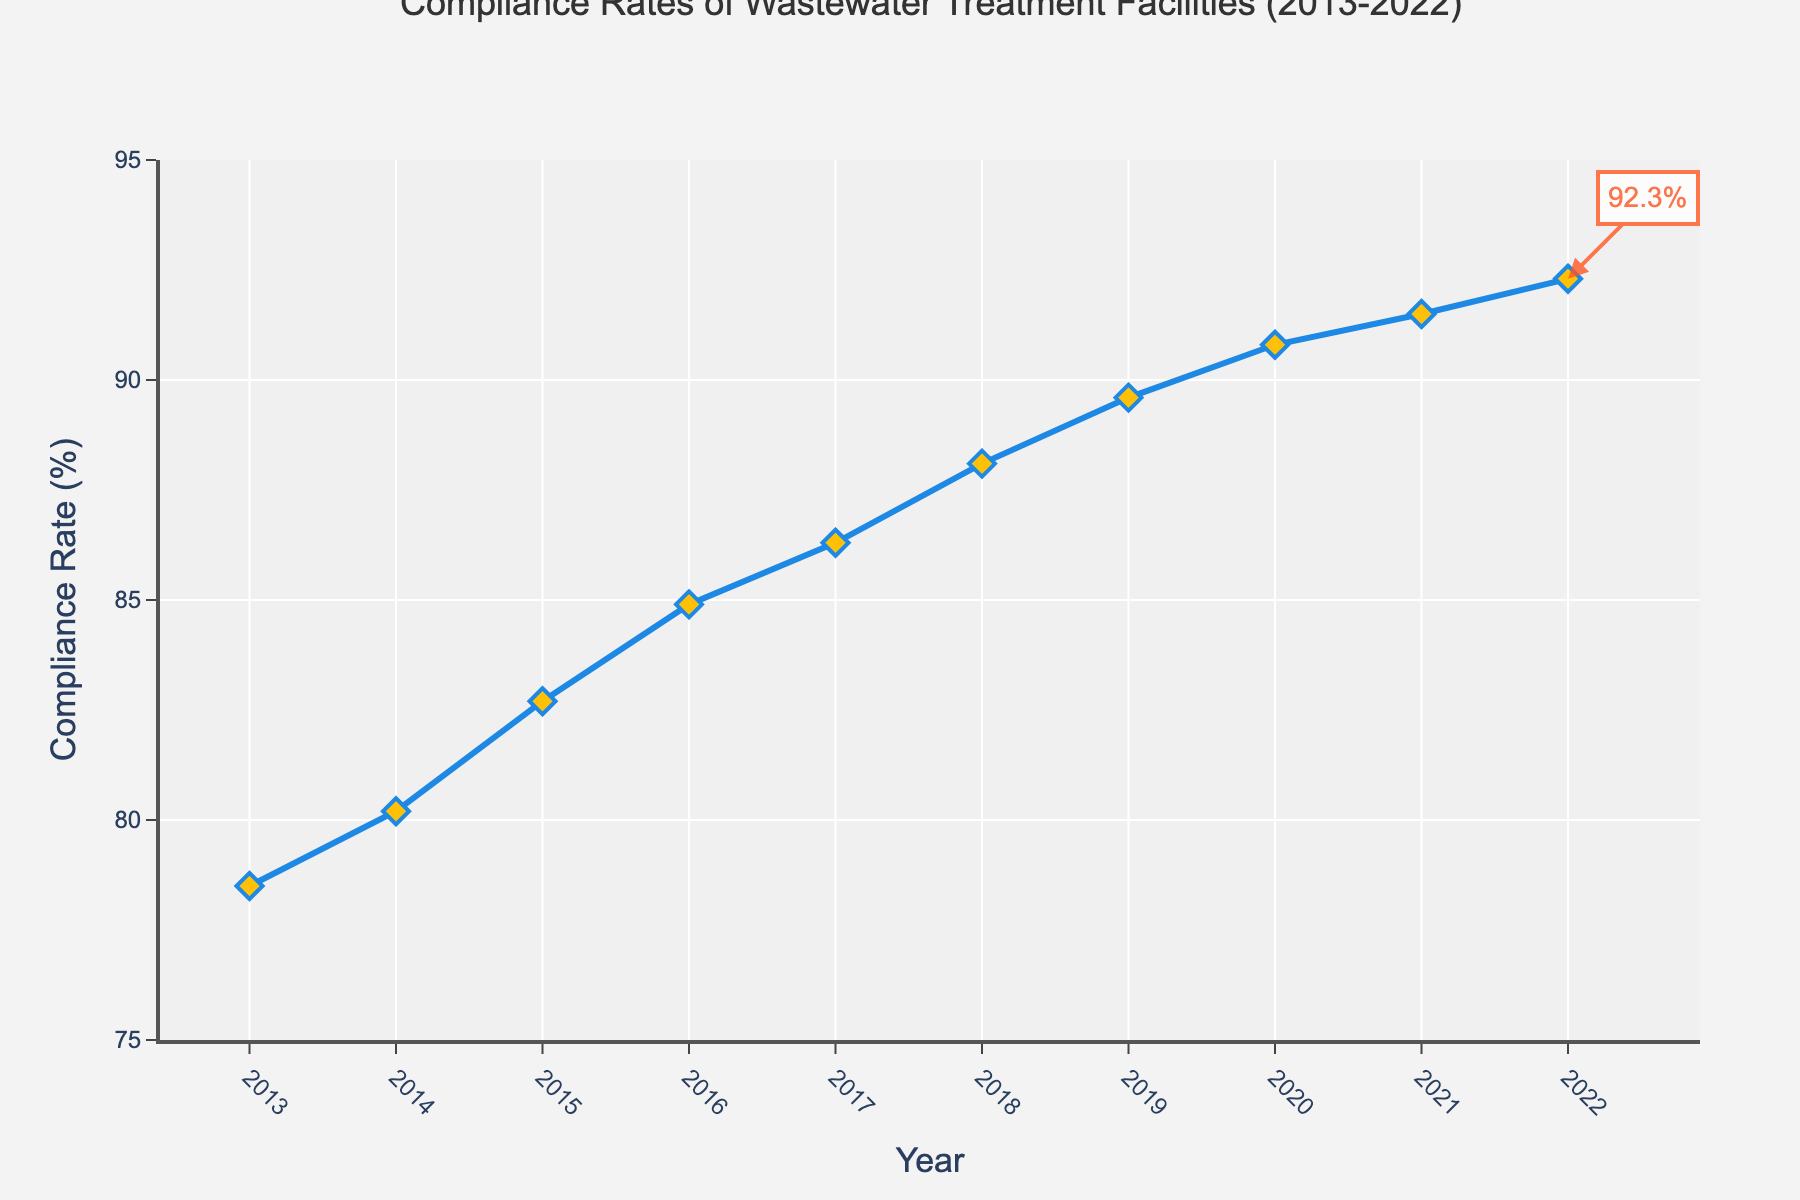What's the average compliance rate over the decade? To find the average compliance rate, sum up all the compliance rates from 2013 to 2022 and then divide by the number of years. The sum is 864.9, and there are 10 years. So, the average is 864.9 / 10.
Answer: 86.49% Which year had the highest compliance rate? The plot shows compliance rates increasing every year, with the highest rate at the last year shown. The latest year is 2022.
Answer: 2022 By how much did the compliance rate increase from 2013 to 2022? From the figure, the compliance rate in 2013 is 78.5%, and in 2022 it is 92.3%. Subtracting the rate of 2013 from 2022 gives the increase. So, 92.3% - 78.5% = 13.8%.
Answer: 13.8% What is the difference in compliance rates between 2016 and 2018? Based on the figure, the compliance rate in 2016 is 84.9%, and in 2018 it is 88.1%. The difference is obtained by subtracting the 2016 rate from the 2018 rate: 88.1% - 84.9% = 3.2%.
Answer: 3.2% Which year saw the largest year-over-year increase in compliance rate? Look at the graph’s slopes between consecutive years, where the steepest slope indicates the largest increase. The steepest slope appears between 2014 and 2015. Checking the values: 82.7% (2015) - 80.2% (2014) = 2.5%
Answer: 2015 What is the compliance rate in 2020? Refer to the plot’s data point for 2020. It shows a compliance rate of 90.8%.
Answer: 90.8% From which year to which year did the compliance rate first surpass 85%? Checking the plotted years, the compliance rate first surpasses 85% in 2017, up from just below 85% in 2016. Thus, it surpassed from the year 2016 to 2017.
Answer: 2016 to 2017 What is the difference between the highest and lowest compliance rates observed in the plot? The highest compliance rate is 92.3% in 2022, and the lowest is 78.5% in 2013. The difference is 92.3% - 78.5% = 13.8%.
Answer: 13.8% Between which consecutive years was the smallest year-over-year increase observed? The smallest slope in the plot suggests the smallest increase. In this case, it appears between 2021 and 2022. Checking the values: 92.3% (2022) - 91.5% (2021) = 0.8%
Answer: 2021 to 2022 